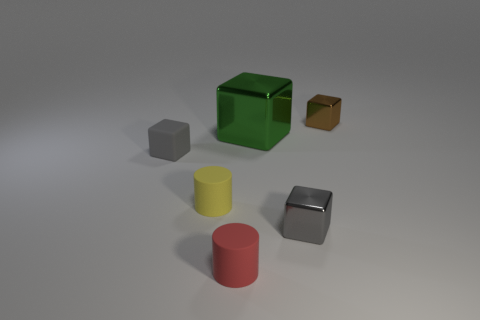Add 4 metal blocks. How many objects exist? 10 Subtract all shiny blocks. How many blocks are left? 1 Subtract all spheres. Subtract all matte objects. How many objects are left? 3 Add 1 tiny yellow objects. How many tiny yellow objects are left? 2 Add 6 rubber cylinders. How many rubber cylinders exist? 8 Subtract all gray cubes. How many cubes are left? 2 Subtract 0 red cubes. How many objects are left? 6 Subtract all cylinders. How many objects are left? 4 Subtract 2 cylinders. How many cylinders are left? 0 Subtract all red blocks. Subtract all brown cylinders. How many blocks are left? 4 